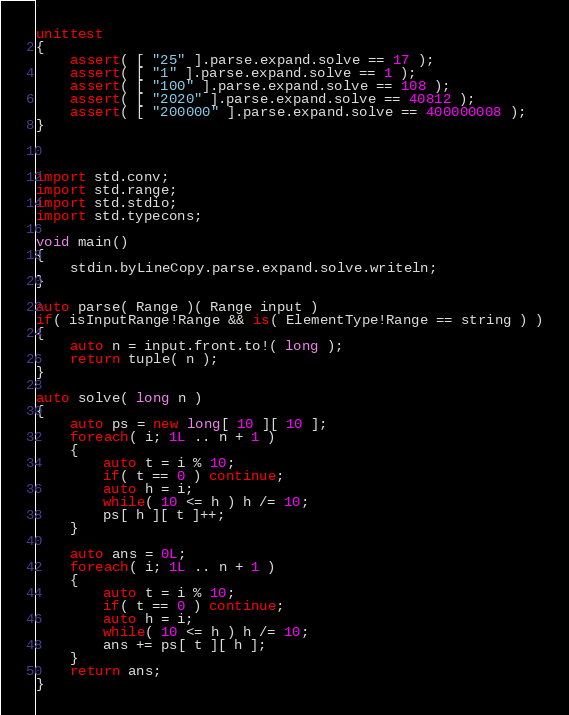<code> <loc_0><loc_0><loc_500><loc_500><_D_>unittest
{
	assert( [ "25" ].parse.expand.solve == 17 );
	assert( [ "1" ].parse.expand.solve == 1 );
	assert( [ "100" ].parse.expand.solve == 108 );
	assert( [ "2020" ].parse.expand.solve == 40812 );
	assert( [ "200000" ].parse.expand.solve == 400000008 );
}



import std.conv;
import std.range;
import std.stdio;
import std.typecons;

void main()
{
	stdin.byLineCopy.parse.expand.solve.writeln;
}

auto parse( Range )( Range input )
if( isInputRange!Range && is( ElementType!Range == string ) )
{
	auto n = input.front.to!( long );
	return tuple( n );
}

auto solve( long n )
{
	auto ps = new long[ 10 ][ 10 ];
	foreach( i; 1L .. n + 1 )
	{
		auto t = i % 10;
		if( t == 0 ) continue;
		auto h = i;
		while( 10 <= h ) h /= 10;
		ps[ h ][ t ]++;
	}
	
	auto ans = 0L;
	foreach( i; 1L .. n + 1 )
	{
		auto t = i % 10;
		if( t == 0 ) continue;
		auto h = i;
		while( 10 <= h ) h /= 10;
		ans += ps[ t ][ h ];
	}
	return ans;
}
</code> 